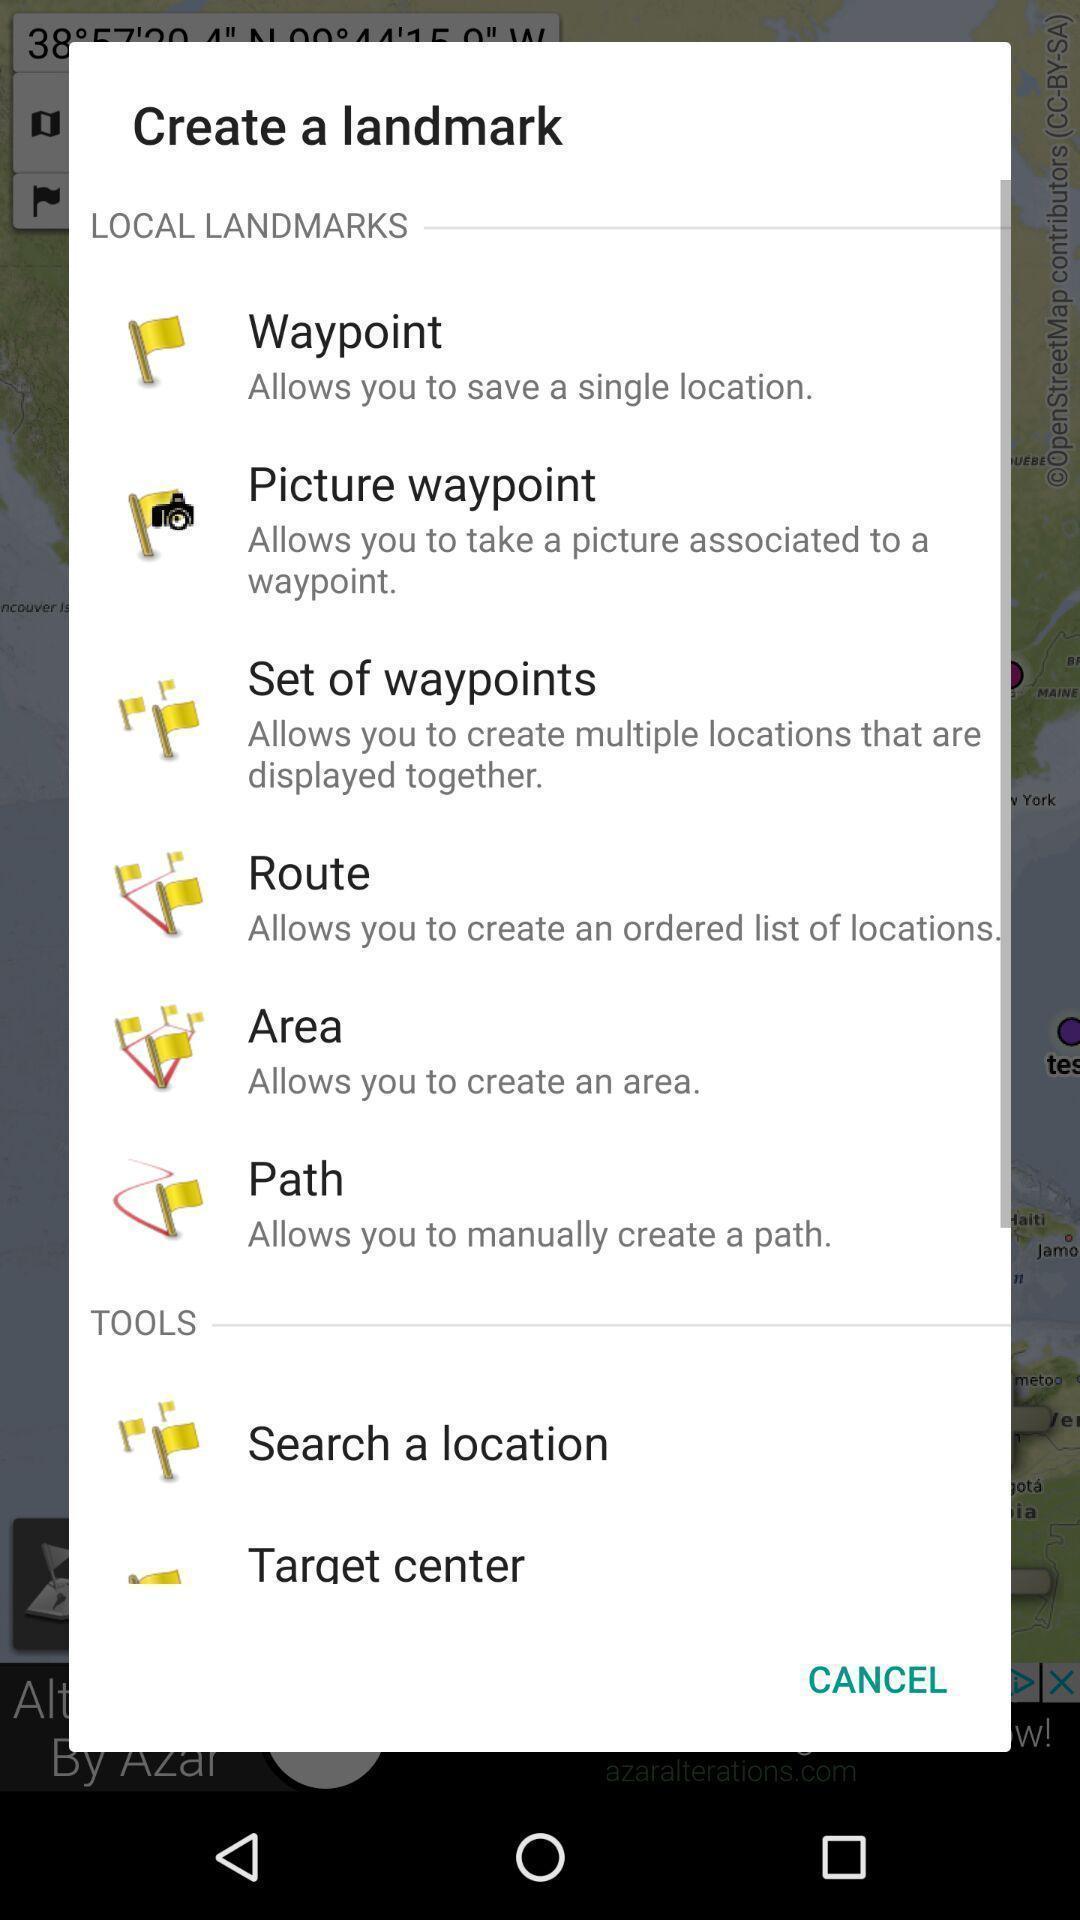Give me a summary of this screen capture. Popup of a screen to create a landmark. 